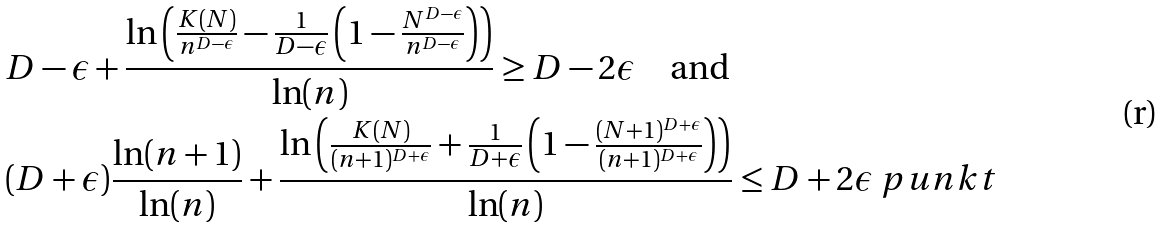Convert formula to latex. <formula><loc_0><loc_0><loc_500><loc_500>& D - \epsilon + \frac { \ln \left ( \frac { K ( N ) } { n ^ { D - \epsilon } } - \frac { 1 } { D - \epsilon } \left ( 1 - \frac { N ^ { D - \epsilon } } { n ^ { D - \epsilon } } \right ) \right ) } { \ln ( n ) } \geq D - 2 \epsilon \quad \text {and} \\ & ( D + \epsilon ) \frac { \ln ( n + 1 ) } { \ln ( n ) } + \frac { \ln \left ( \frac { K ( N ) } { ( n + 1 ) ^ { D + \epsilon } } + \frac { 1 } { D + \epsilon } \left ( 1 - \frac { ( N + 1 ) ^ { D + \epsilon } } { ( n + 1 ) ^ { D + \epsilon } } \right ) \right ) } { \ln ( n ) } \leq D + 2 \epsilon \ p u n k t</formula> 